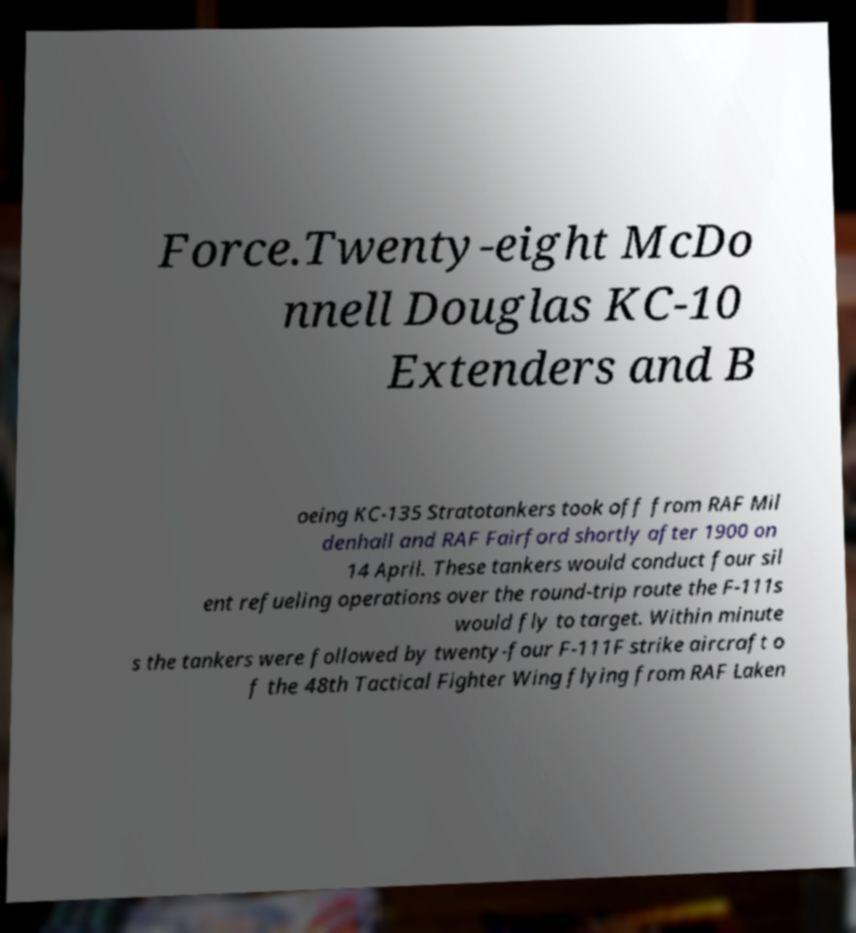There's text embedded in this image that I need extracted. Can you transcribe it verbatim? Force.Twenty-eight McDo nnell Douglas KC-10 Extenders and B oeing KC-135 Stratotankers took off from RAF Mil denhall and RAF Fairford shortly after 1900 on 14 April. These tankers would conduct four sil ent refueling operations over the round-trip route the F-111s would fly to target. Within minute s the tankers were followed by twenty-four F-111F strike aircraft o f the 48th Tactical Fighter Wing flying from RAF Laken 